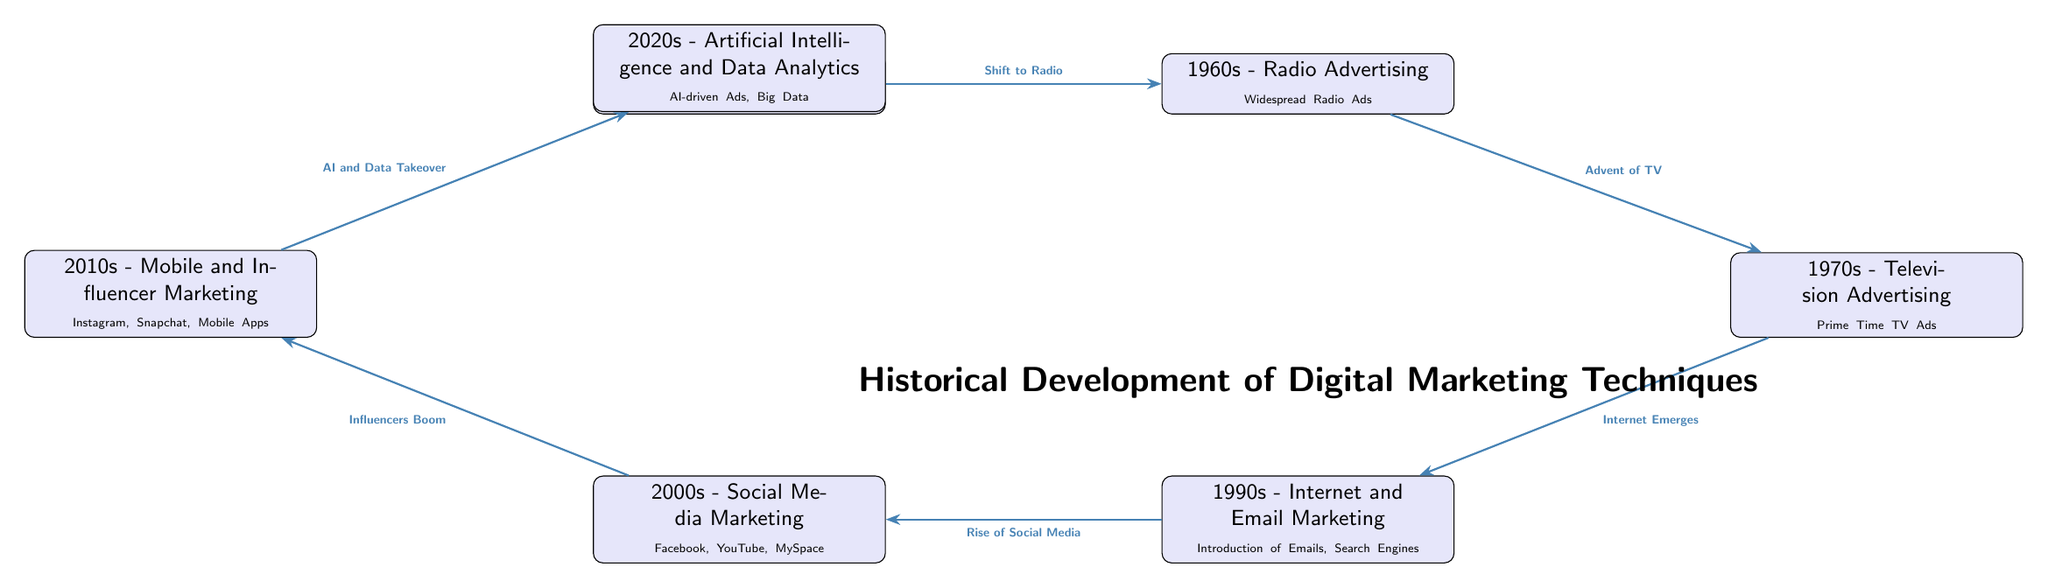What is the marketing technique introduced in the 1950s? The diagram indicates that the marketing technique in the 1950s was "Print Media," which includes newspapers, magazines, and billboards.
Answer: Print Media Which decade introduced "Television Advertising"? According to the timeline in the diagram, "Television Advertising" was introduced in the 1970s.
Answer: 1970s How many marketing techniques are listed in the diagram? By counting the nodes in the diagram, we can see there are a total of seven marketing techniques mentioned, from the 1950s to the 2020s.
Answer: 7 What is the relationship between "2000s - Social Media Marketing" and "2010s - Mobile and Influencer Marketing"? The arrow from the 2000s node to the 2010s node signifies an "Influencers Boom" that connects these two marketing techniques across decades.
Answer: Influencers Boom What milestone indicates the transition from "Television Advertising" to "Internet and Email Marketing"? The transition highlighted in the diagram is labeled as "Internet Emerges" which occurs between the 1970s and the 1990s.
Answer: Internet Emerges Which technology is associated with the 2020s marketing strategies? The diagram specifies that the 2020s marketing strategies focus on "Artificial Intelligence and Data Analytics."
Answer: Artificial Intelligence and Data Analytics What does the flow from the 1990s to the 2000s represent? The flow from the 1990s to the 2000s is represented as the "Rise of Social Media," indicating a progression in digital marketing techniques.
Answer: Rise of Social Media What was a major factor that led to the adoption of "Mobile and Influencer Marketing" in the 2010s? The guiding factor for the shift detailed in the diagram is the boom in influencers that occurred in the 2000s.
Answer: Influencers Boom Which marketing technique was a significant technological advancement introduced in the 2020s? The diagram outlines "AI-driven Ads and Big Data" as significant advancements in marketing techniques for the 2020s.
Answer: AI-driven Ads and Big Data 